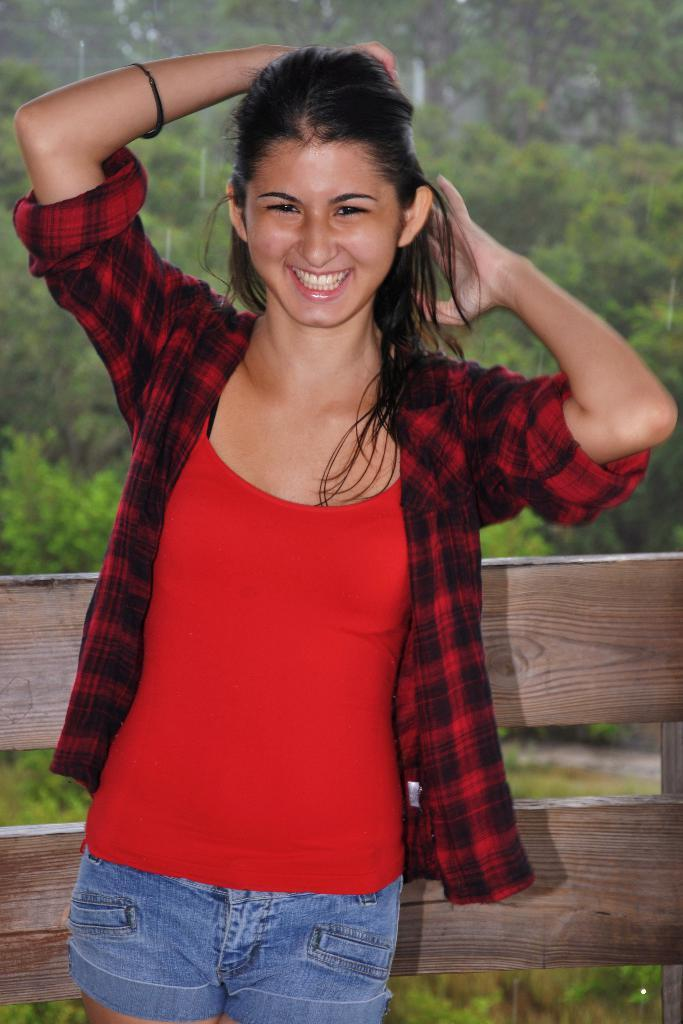Who is the main subject in the image? There is a woman in the image. What is the woman wearing? The woman is wearing a red dress. What expression does the woman have? The woman is smiling. What can be seen behind the woman? There is a wooden fence behind the woman. What is visible in the background of the image? There are trees in the background of the image. How many leather apples can be seen in the image? There are no leather apples present in the image. 